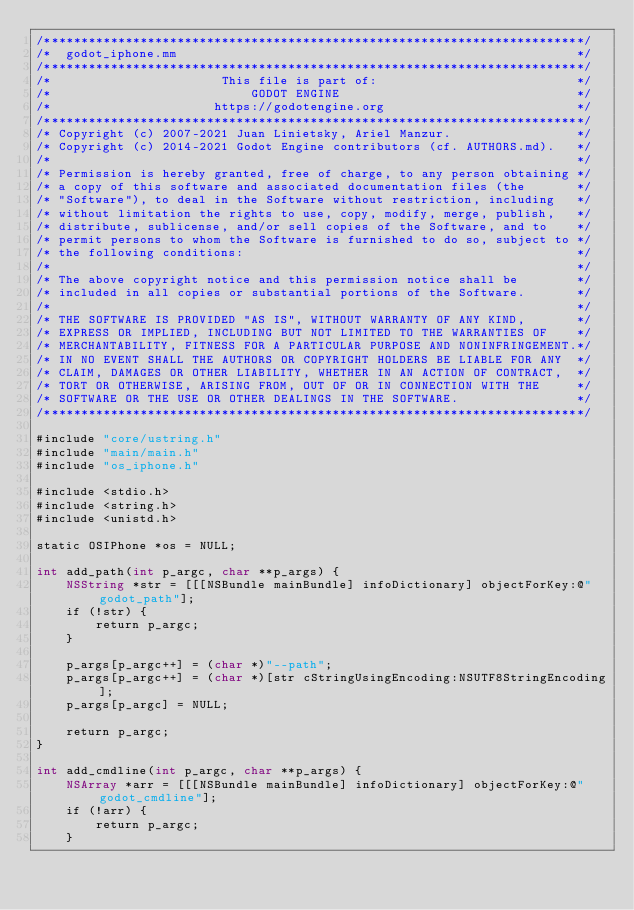<code> <loc_0><loc_0><loc_500><loc_500><_ObjectiveC_>/*************************************************************************/
/*  godot_iphone.mm                                                      */
/*************************************************************************/
/*                       This file is part of:                           */
/*                           GODOT ENGINE                                */
/*                      https://godotengine.org                          */
/*************************************************************************/
/* Copyright (c) 2007-2021 Juan Linietsky, Ariel Manzur.                 */
/* Copyright (c) 2014-2021 Godot Engine contributors (cf. AUTHORS.md).   */
/*                                                                       */
/* Permission is hereby granted, free of charge, to any person obtaining */
/* a copy of this software and associated documentation files (the       */
/* "Software"), to deal in the Software without restriction, including   */
/* without limitation the rights to use, copy, modify, merge, publish,   */
/* distribute, sublicense, and/or sell copies of the Software, and to    */
/* permit persons to whom the Software is furnished to do so, subject to */
/* the following conditions:                                             */
/*                                                                       */
/* The above copyright notice and this permission notice shall be        */
/* included in all copies or substantial portions of the Software.       */
/*                                                                       */
/* THE SOFTWARE IS PROVIDED "AS IS", WITHOUT WARRANTY OF ANY KIND,       */
/* EXPRESS OR IMPLIED, INCLUDING BUT NOT LIMITED TO THE WARRANTIES OF    */
/* MERCHANTABILITY, FITNESS FOR A PARTICULAR PURPOSE AND NONINFRINGEMENT.*/
/* IN NO EVENT SHALL THE AUTHORS OR COPYRIGHT HOLDERS BE LIABLE FOR ANY  */
/* CLAIM, DAMAGES OR OTHER LIABILITY, WHETHER IN AN ACTION OF CONTRACT,  */
/* TORT OR OTHERWISE, ARISING FROM, OUT OF OR IN CONNECTION WITH THE     */
/* SOFTWARE OR THE USE OR OTHER DEALINGS IN THE SOFTWARE.                */
/*************************************************************************/

#include "core/ustring.h"
#include "main/main.h"
#include "os_iphone.h"

#include <stdio.h>
#include <string.h>
#include <unistd.h>

static OSIPhone *os = NULL;

int add_path(int p_argc, char **p_args) {
	NSString *str = [[[NSBundle mainBundle] infoDictionary] objectForKey:@"godot_path"];
	if (!str) {
		return p_argc;
	}

	p_args[p_argc++] = (char *)"--path";
	p_args[p_argc++] = (char *)[str cStringUsingEncoding:NSUTF8StringEncoding];
	p_args[p_argc] = NULL;

	return p_argc;
}

int add_cmdline(int p_argc, char **p_args) {
	NSArray *arr = [[[NSBundle mainBundle] infoDictionary] objectForKey:@"godot_cmdline"];
	if (!arr) {
		return p_argc;
	}
</code> 